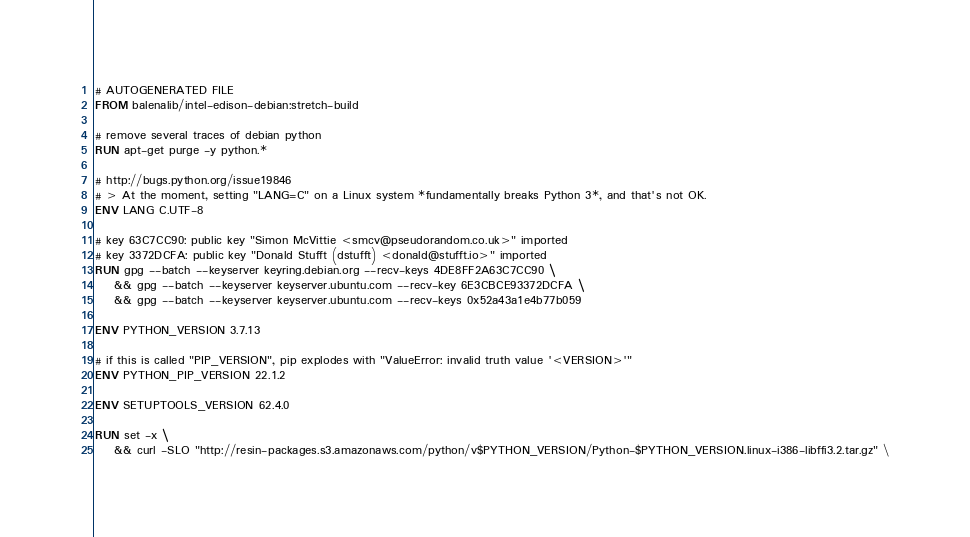Convert code to text. <code><loc_0><loc_0><loc_500><loc_500><_Dockerfile_># AUTOGENERATED FILE
FROM balenalib/intel-edison-debian:stretch-build

# remove several traces of debian python
RUN apt-get purge -y python.*

# http://bugs.python.org/issue19846
# > At the moment, setting "LANG=C" on a Linux system *fundamentally breaks Python 3*, and that's not OK.
ENV LANG C.UTF-8

# key 63C7CC90: public key "Simon McVittie <smcv@pseudorandom.co.uk>" imported
# key 3372DCFA: public key "Donald Stufft (dstufft) <donald@stufft.io>" imported
RUN gpg --batch --keyserver keyring.debian.org --recv-keys 4DE8FF2A63C7CC90 \
    && gpg --batch --keyserver keyserver.ubuntu.com --recv-key 6E3CBCE93372DCFA \
    && gpg --batch --keyserver keyserver.ubuntu.com --recv-keys 0x52a43a1e4b77b059

ENV PYTHON_VERSION 3.7.13

# if this is called "PIP_VERSION", pip explodes with "ValueError: invalid truth value '<VERSION>'"
ENV PYTHON_PIP_VERSION 22.1.2

ENV SETUPTOOLS_VERSION 62.4.0

RUN set -x \
    && curl -SLO "http://resin-packages.s3.amazonaws.com/python/v$PYTHON_VERSION/Python-$PYTHON_VERSION.linux-i386-libffi3.2.tar.gz" \</code> 